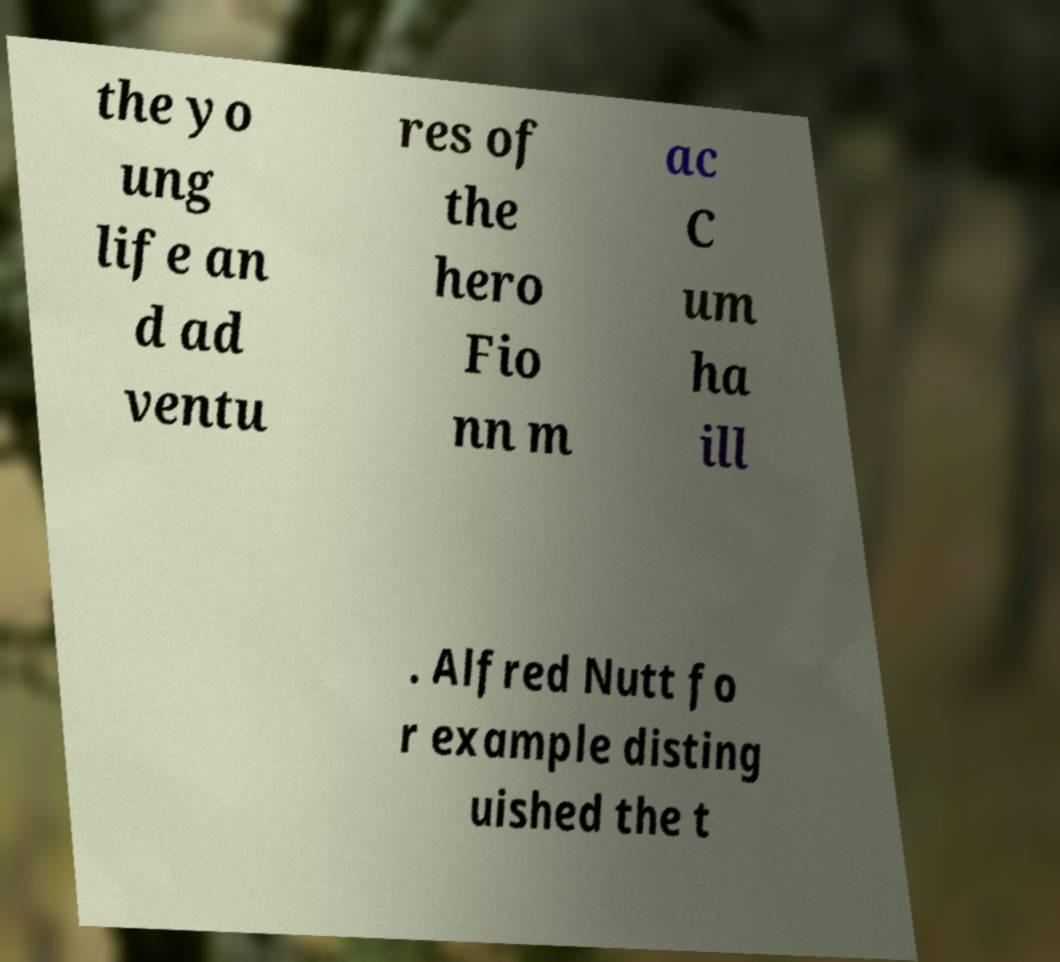Could you assist in decoding the text presented in this image and type it out clearly? the yo ung life an d ad ventu res of the hero Fio nn m ac C um ha ill . Alfred Nutt fo r example disting uished the t 